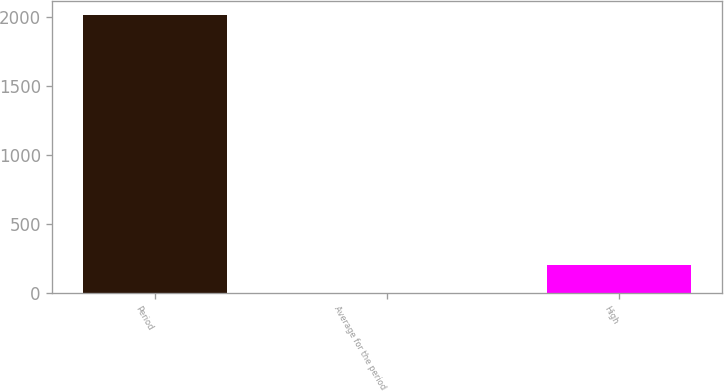Convert chart to OTSL. <chart><loc_0><loc_0><loc_500><loc_500><bar_chart><fcel>Period<fcel>Average for the period<fcel>High<nl><fcel>2014<fcel>1<fcel>202.3<nl></chart> 